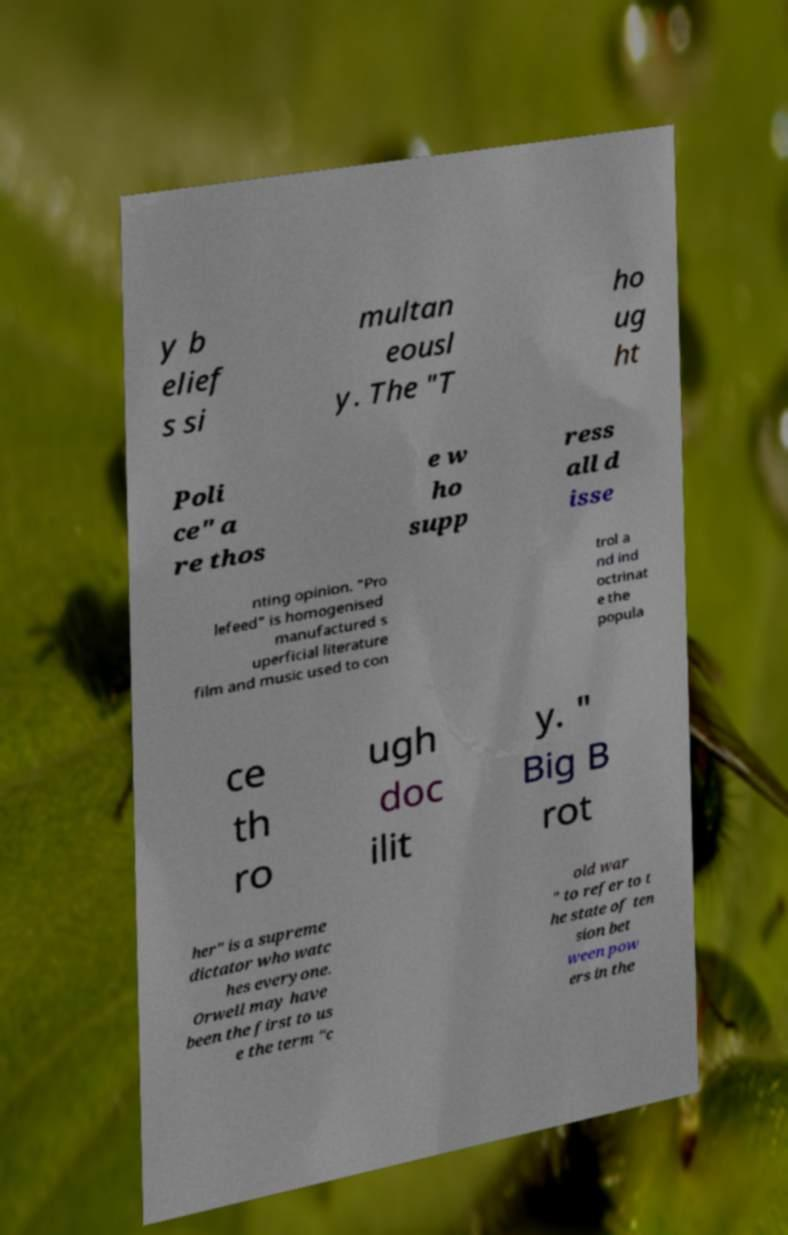For documentation purposes, I need the text within this image transcribed. Could you provide that? y b elief s si multan eousl y. The "T ho ug ht Poli ce" a re thos e w ho supp ress all d isse nting opinion. "Pro lefeed" is homogenised manufactured s uperficial literature film and music used to con trol a nd ind octrinat e the popula ce th ro ugh doc ilit y. " Big B rot her" is a supreme dictator who watc hes everyone. Orwell may have been the first to us e the term "c old war " to refer to t he state of ten sion bet ween pow ers in the 